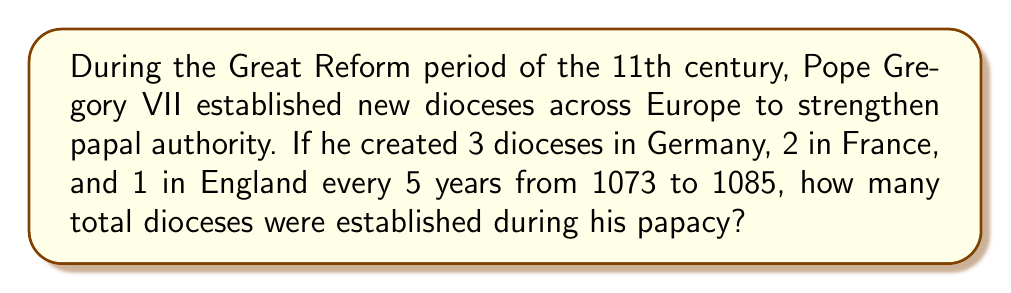Show me your answer to this math problem. To solve this problem, we need to follow these steps:

1. Calculate the duration of Pope Gregory VII's papacy:
   - Papacy started in 1073 and ended in 1085
   - Total years = 1085 - 1073 + 1 = 13 years

2. Determine the number of 5-year periods in 13 years:
   $$ \text{Number of periods} = \left\lfloor\frac{13}{5}\right\rfloor = 2 $$
   Where $\lfloor \rfloor$ denotes the floor function.

3. Calculate the number of dioceses established per 5-year period:
   - Germany: 3
   - France: 2
   - England: 1
   $$ \text{Total per period} = 3 + 2 + 1 = 6 $$

4. Multiply the number of periods by the dioceses established per period:
   $$ \text{Total dioceses} = 2 \times 6 = 12 $$

Therefore, Pope Gregory VII established 12 dioceses during his papacy from 1073 to 1085.
Answer: 12 dioceses 